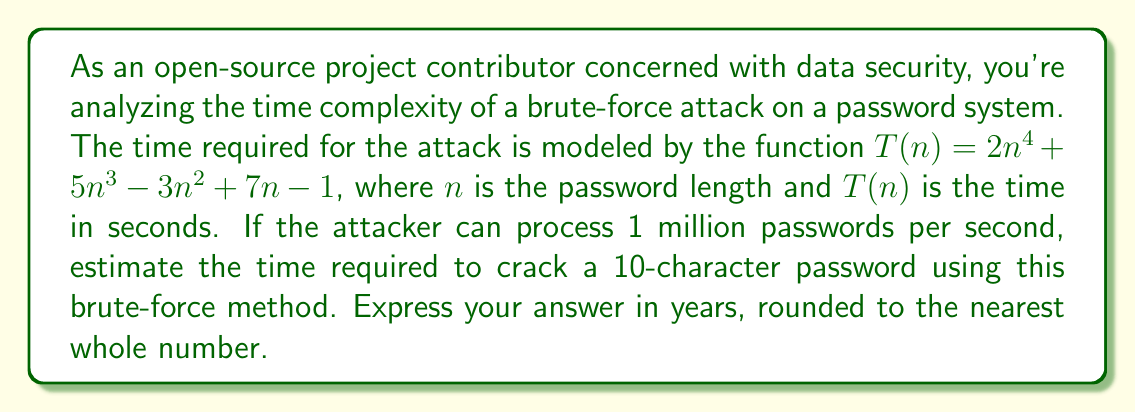Show me your answer to this math problem. To solve this problem, we'll follow these steps:

1) First, we need to calculate $T(10)$ since the password length is 10 characters:

   $T(10) = 2(10^4) + 5(10^3) - 3(10^2) + 7(10) - 1$
   $= 20000 + 5000 - 300 + 70 - 1$
   $= 24769$ seconds

2) This value represents the number of passwords that need to be tried. However, the attacker can process 1 million passwords per second. So we need to divide our result by 1,000,000:

   $24769 / 1000000 = 0.024769$ seconds

3) To convert this to years, we need to divide by the number of seconds in a year:

   Seconds in a year $= 365 \times 24 \times 60 \times 60 = 31536000$

   Years $= 0.024769 / 31536000 = 7.854 \times 10^{-10}$ years

4) Rounding to the nearest whole number:

   $7.854 \times 10^{-10}$ rounds to 0 years

Therefore, the estimated time to crack the password is effectively 0 years when rounded to the nearest whole number.
Answer: 0 years 